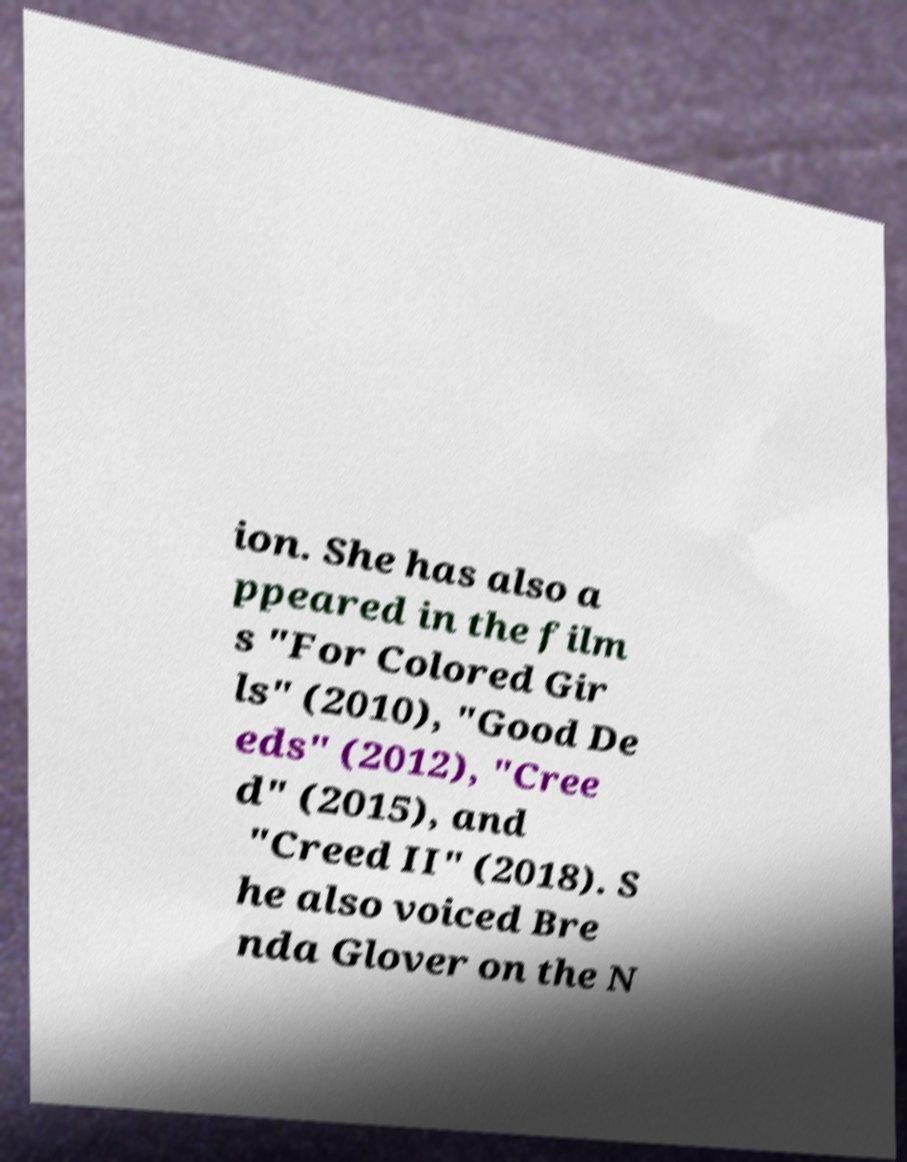Could you extract and type out the text from this image? ion. She has also a ppeared in the film s "For Colored Gir ls" (2010), "Good De eds" (2012), "Cree d" (2015), and "Creed II" (2018). S he also voiced Bre nda Glover on the N 